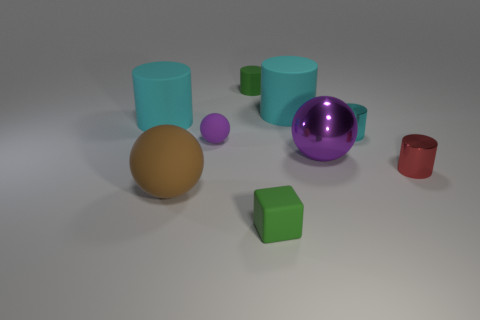Subtract all purple blocks. How many cyan cylinders are left? 3 Subtract all tiny green cylinders. How many cylinders are left? 4 Subtract all green cylinders. How many cylinders are left? 4 Subtract all brown cylinders. Subtract all purple blocks. How many cylinders are left? 5 Add 1 small red cylinders. How many objects exist? 10 Subtract all cylinders. How many objects are left? 4 Add 3 green rubber cylinders. How many green rubber cylinders are left? 4 Add 2 tiny blue metallic spheres. How many tiny blue metallic spheres exist? 2 Subtract 1 green cylinders. How many objects are left? 8 Subtract all tiny green rubber cylinders. Subtract all purple rubber spheres. How many objects are left? 7 